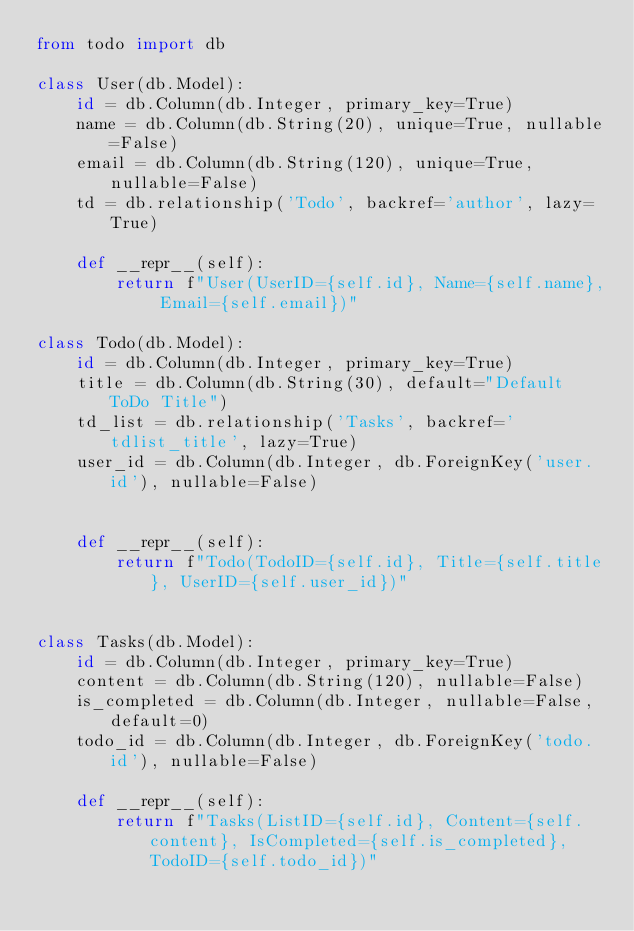<code> <loc_0><loc_0><loc_500><loc_500><_Python_>from todo import db

class User(db.Model):
    id = db.Column(db.Integer, primary_key=True)
    name = db.Column(db.String(20), unique=True, nullable=False)
    email = db.Column(db.String(120), unique=True, nullable=False)
    td = db.relationship('Todo', backref='author', lazy=True)

    def __repr__(self):
        return f"User(UserID={self.id}, Name={self.name}, Email={self.email})"

class Todo(db.Model):
    id = db.Column(db.Integer, primary_key=True)
    title = db.Column(db.String(30), default="Default ToDo Title")
    td_list = db.relationship('Tasks', backref='tdlist_title', lazy=True)
    user_id = db.Column(db.Integer, db.ForeignKey('user.id'), nullable=False)
    

    def __repr__(self):
        return f"Todo(TodoID={self.id}, Title={self.title}, UserID={self.user_id})"


class Tasks(db.Model):
    id = db.Column(db.Integer, primary_key=True)
    content = db.Column(db.String(120), nullable=False)
    is_completed = db.Column(db.Integer, nullable=False, default=0)
    todo_id = db.Column(db.Integer, db.ForeignKey('todo.id'), nullable=False)

    def __repr__(self):
        return f"Tasks(ListID={self.id}, Content={self.content}, IsCompleted={self.is_completed}, TodoID={self.todo_id})"
</code> 